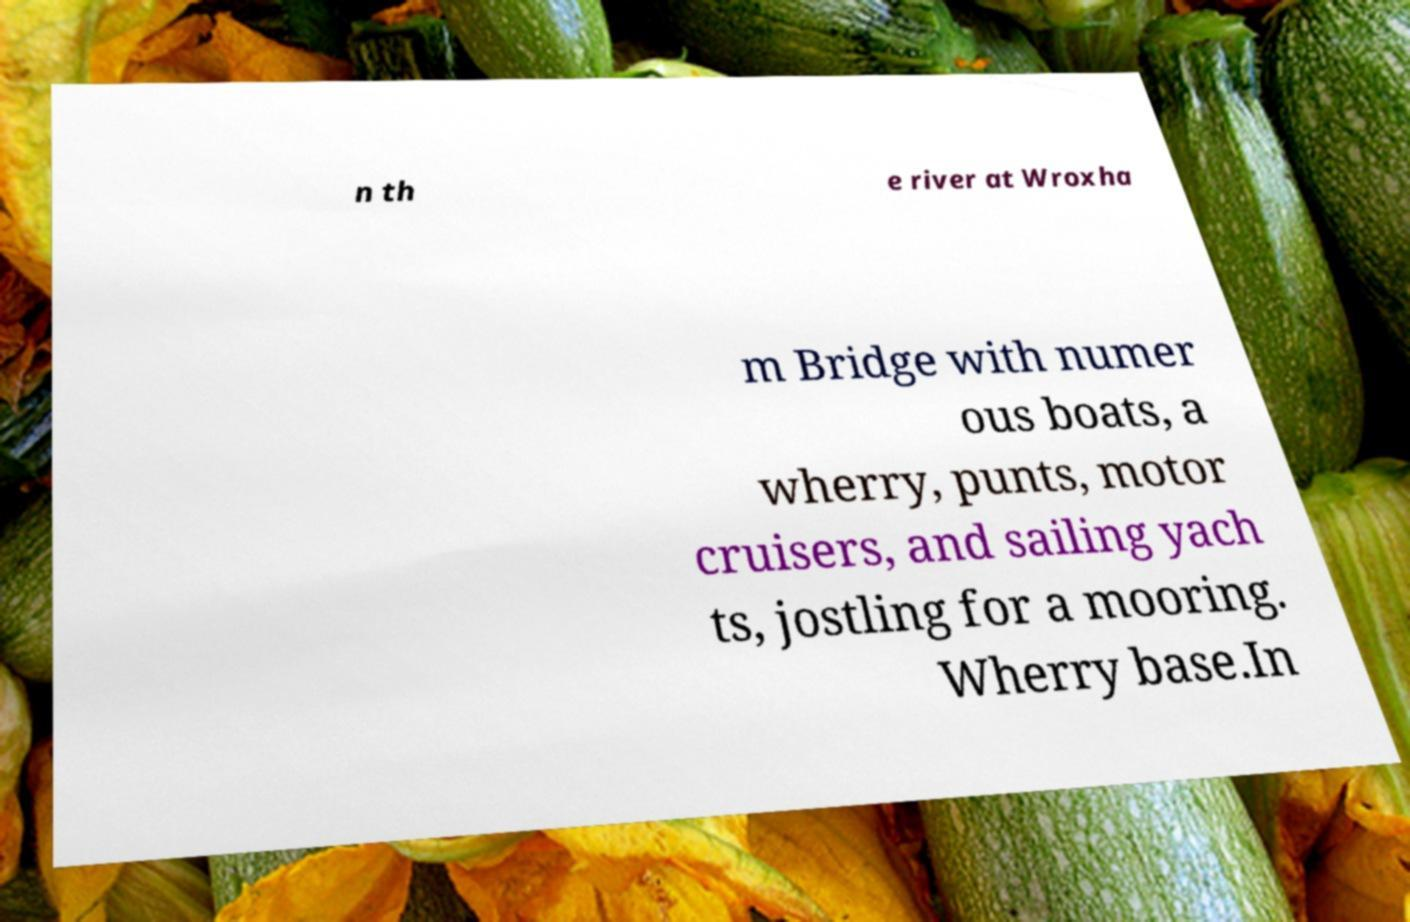Please read and relay the text visible in this image. What does it say? n th e river at Wroxha m Bridge with numer ous boats, a wherry, punts, motor cruisers, and sailing yach ts, jostling for a mooring. Wherry base.In 